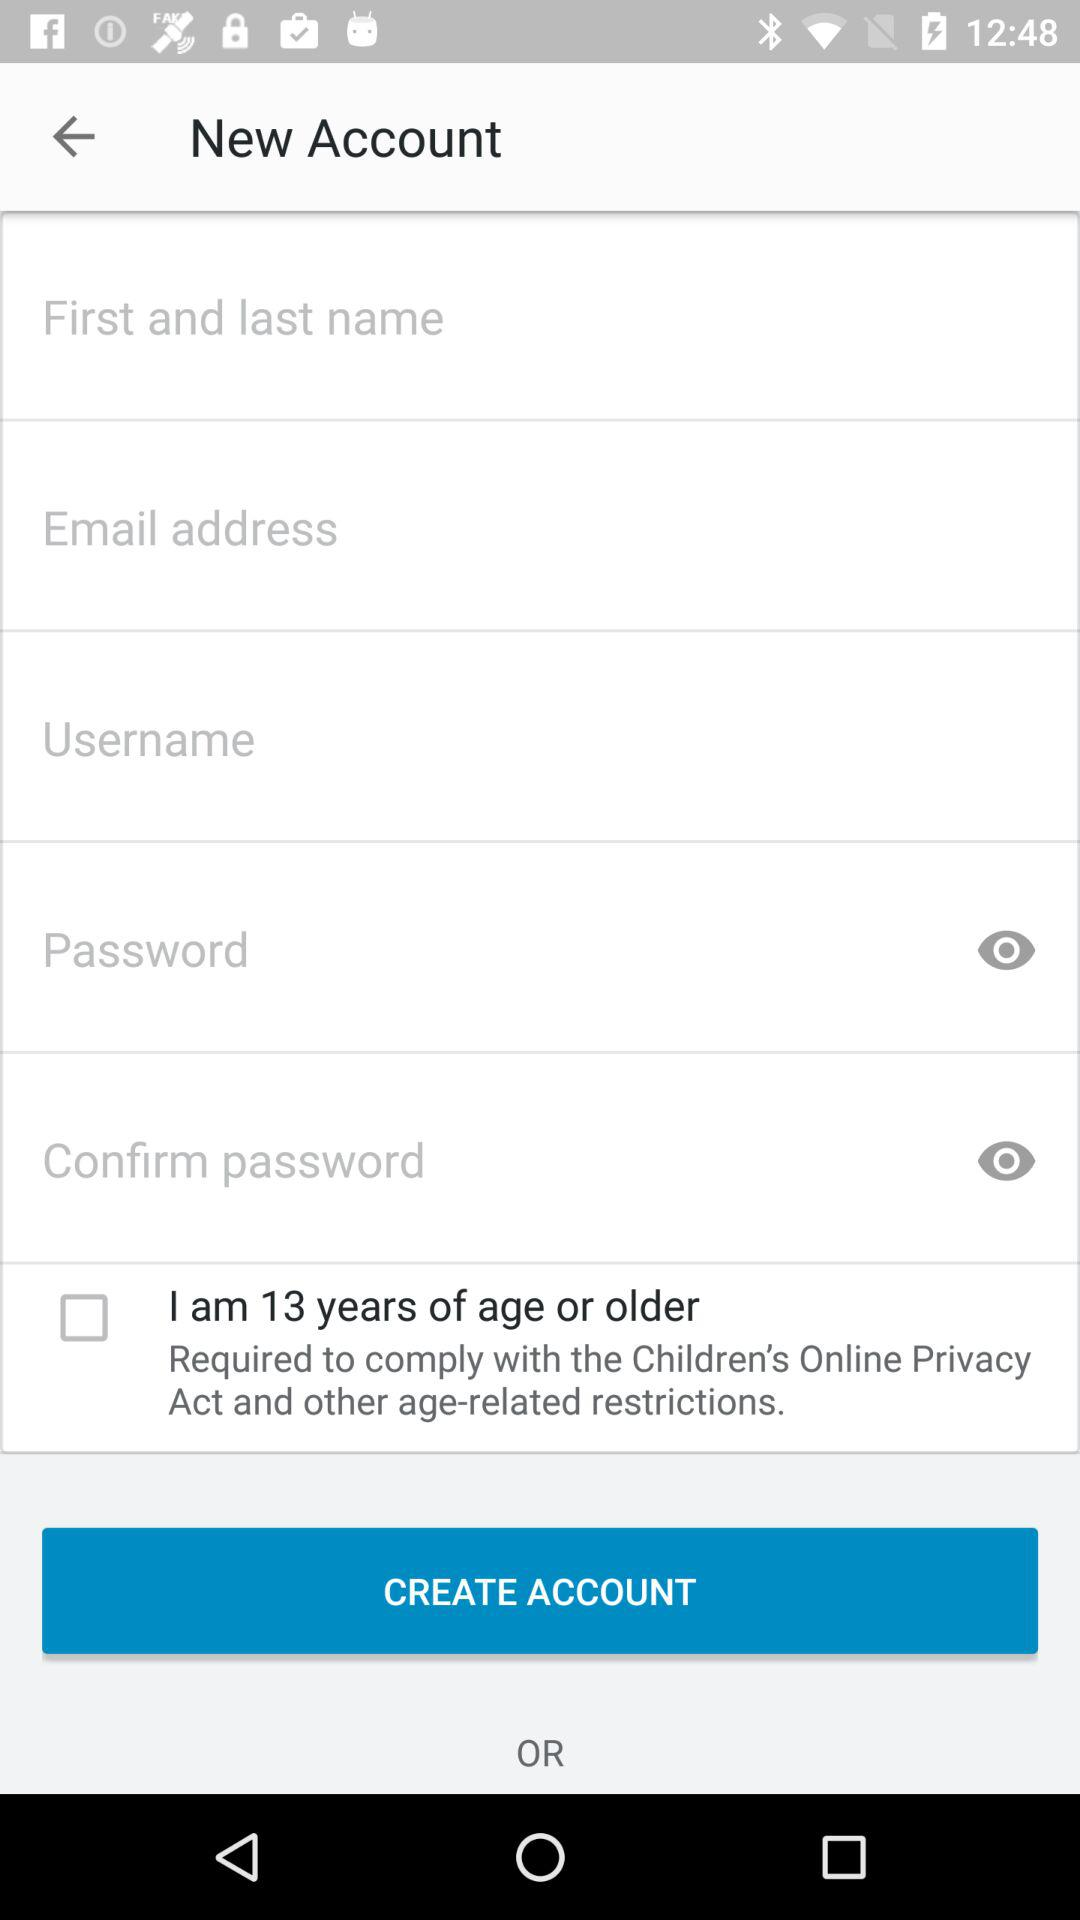What is the status of "I am 13 years of age or older"? The status is "off". 